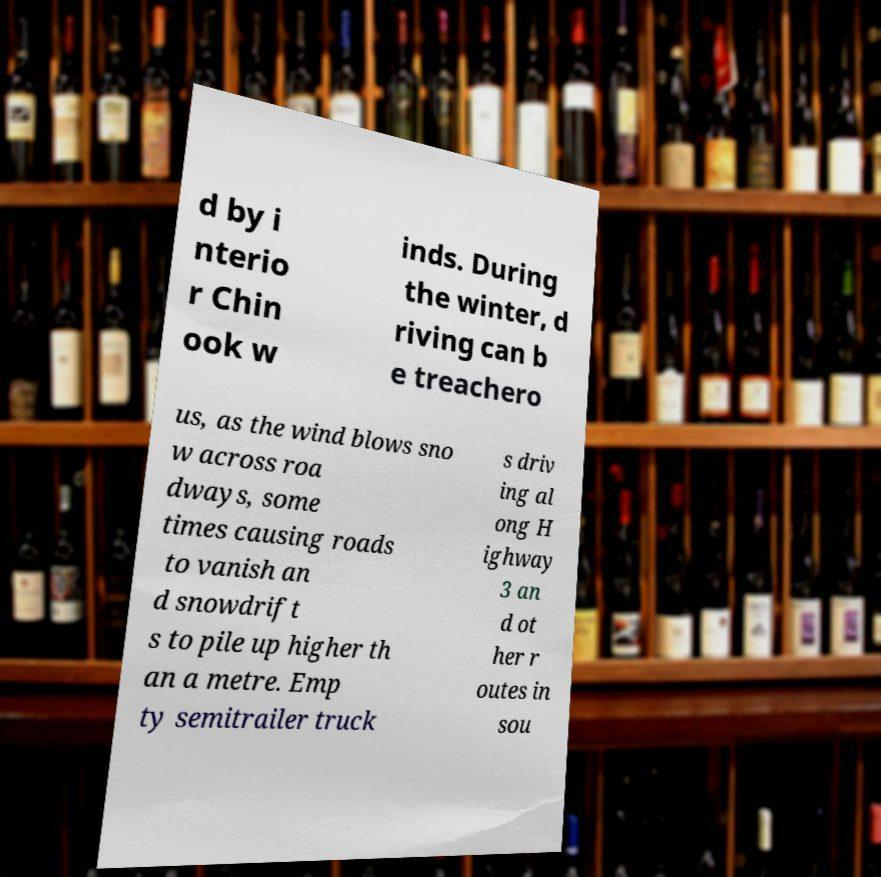What messages or text are displayed in this image? I need them in a readable, typed format. d by i nterio r Chin ook w inds. During the winter, d riving can b e treachero us, as the wind blows sno w across roa dways, some times causing roads to vanish an d snowdrift s to pile up higher th an a metre. Emp ty semitrailer truck s driv ing al ong H ighway 3 an d ot her r outes in sou 